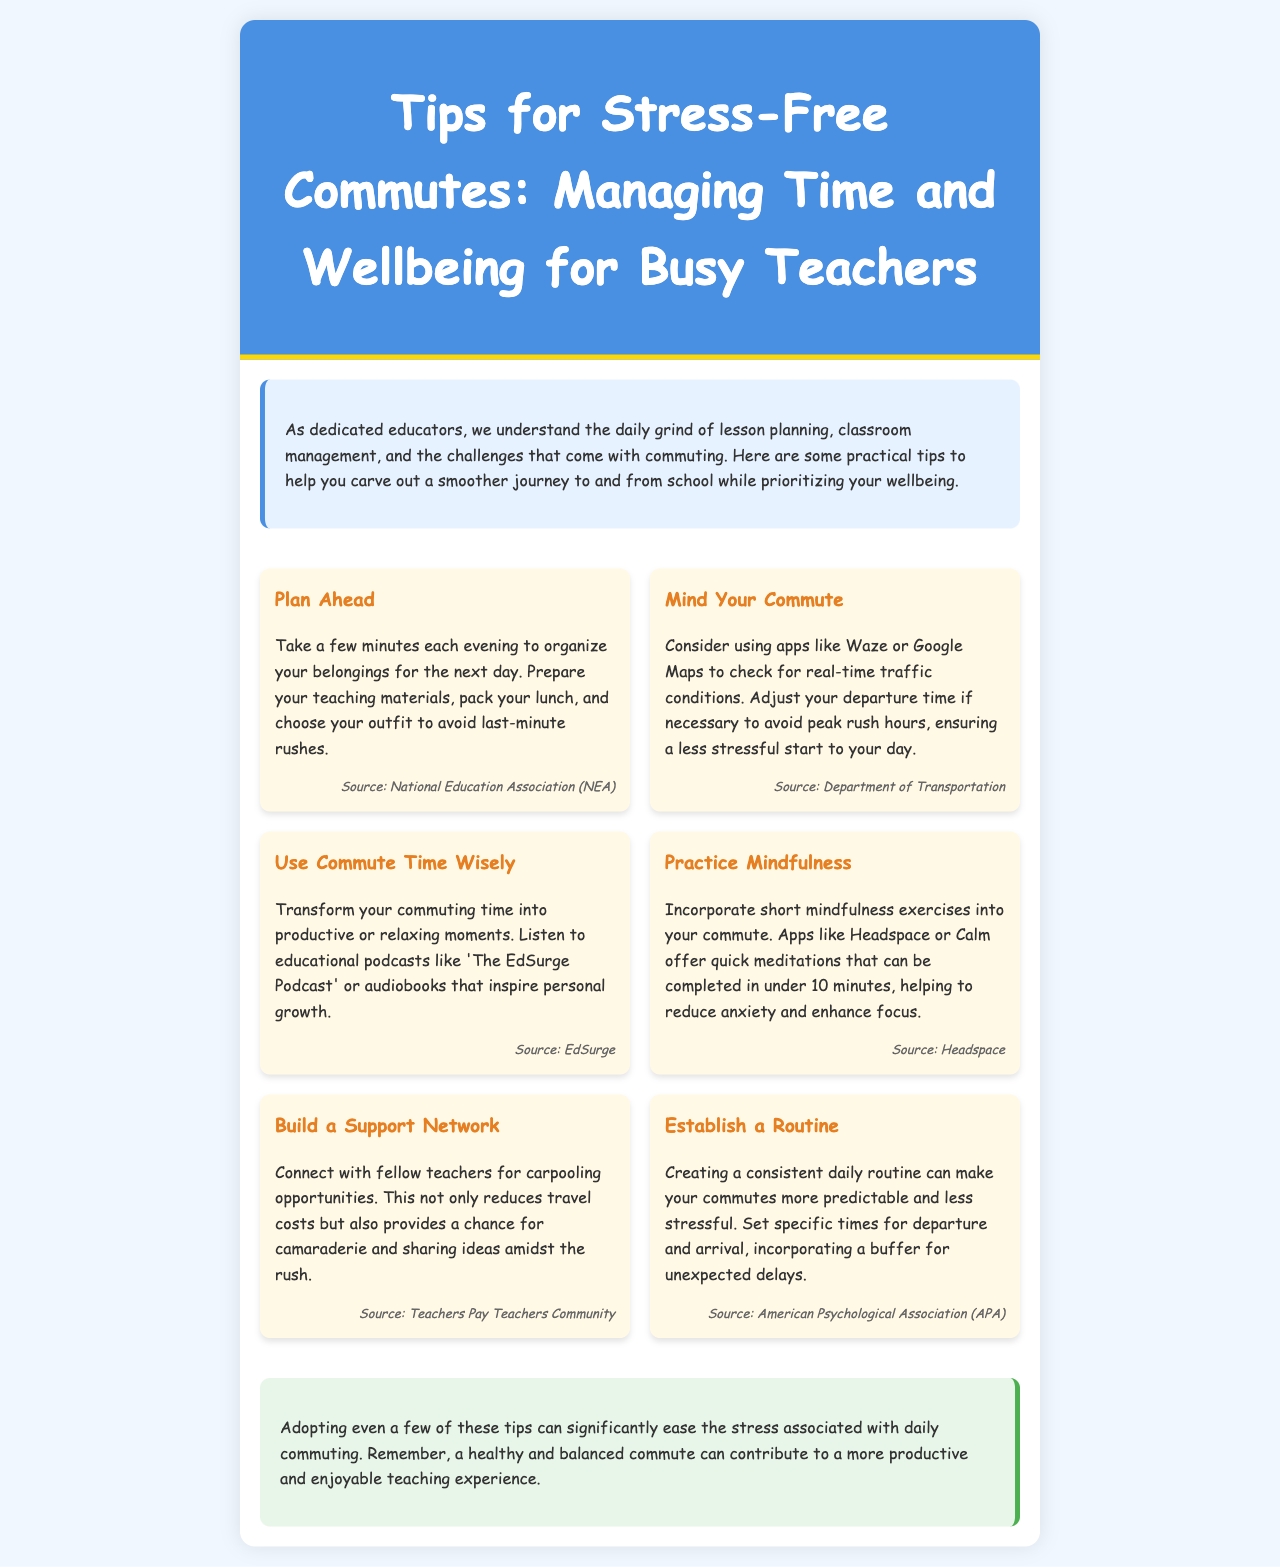What is the title of the newsletter? The title of the newsletter is presented prominently at the top of the document.
Answer: Tips for Stress-Free Commutes: Managing Time and Wellbeing for Busy Teachers Who is the target audience of the newsletter? The content of the newsletter is specifically designed to support a particular group of professionals.
Answer: Busy teachers What is one app mentioned for checking traffic conditions? The document cites specific apps that can be used to monitor real-time traffic.
Answer: Waze How many tips are provided in the newsletter? The newsletter lists multiple tips for commuting, which can be counted.
Answer: Six What does the tip "Practice Mindfulness" suggest using? This tip advises the use of specific applications for meditative practices.
Answer: Headspace What is one benefit of carpooling mentioned in the newsletter? The newsletter discusses advantages of connecting with fellow teachers for shared transportation.
Answer: Reduces travel costs What activity can be done during commute time according to the document? The newsletter encourages productive use of commuting time through certain activities.
Answer: Listening to podcasts What is a suggested method to establish a routine? The document recommends specific strategies for timing during daily commutes.
Answer: Set specific times for departure and arrival 